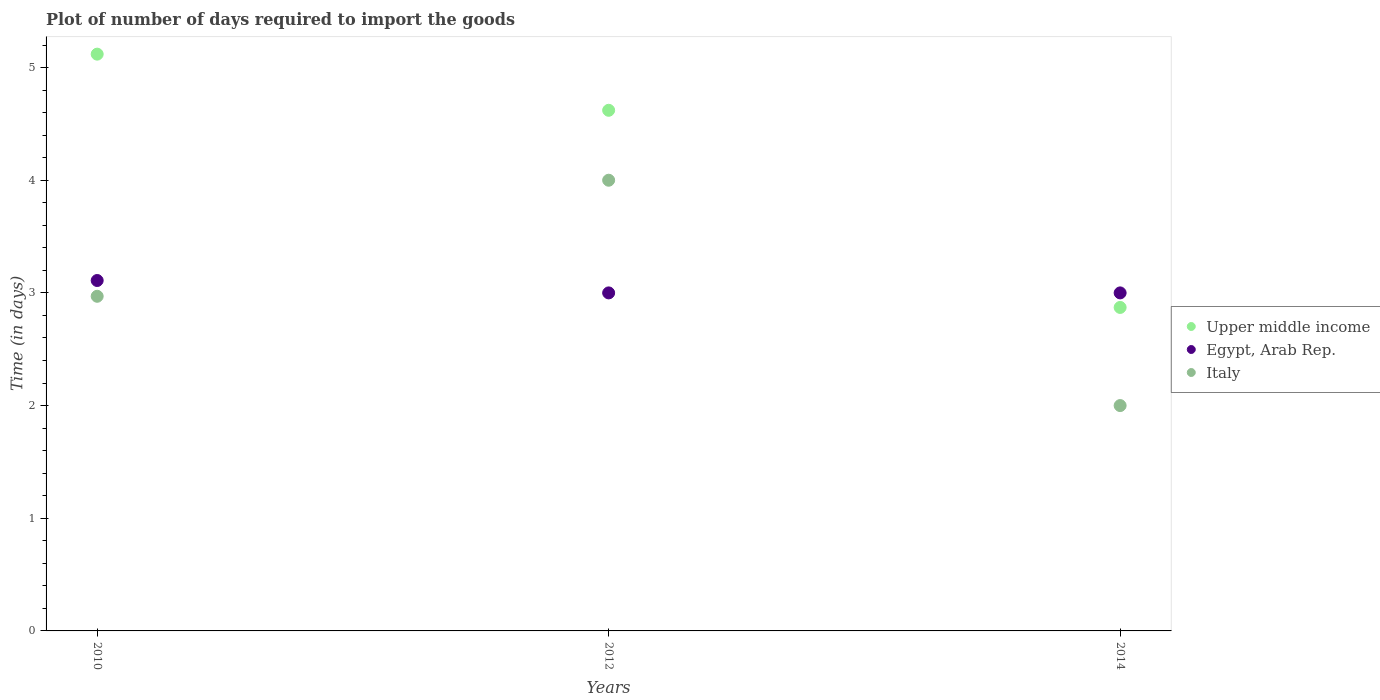How many different coloured dotlines are there?
Offer a very short reply. 3. What is the time required to import goods in Upper middle income in 2010?
Ensure brevity in your answer.  5.12. Across all years, what is the maximum time required to import goods in Egypt, Arab Rep.?
Give a very brief answer. 3.11. Across all years, what is the minimum time required to import goods in Upper middle income?
Your answer should be very brief. 2.87. In which year was the time required to import goods in Egypt, Arab Rep. maximum?
Your response must be concise. 2010. What is the total time required to import goods in Egypt, Arab Rep. in the graph?
Give a very brief answer. 9.11. What is the difference between the time required to import goods in Egypt, Arab Rep. in 2010 and that in 2012?
Keep it short and to the point. 0.11. What is the difference between the time required to import goods in Italy in 2014 and the time required to import goods in Upper middle income in 2010?
Provide a short and direct response. -3.12. What is the average time required to import goods in Italy per year?
Give a very brief answer. 2.99. What is the ratio of the time required to import goods in Upper middle income in 2010 to that in 2014?
Provide a succinct answer. 1.78. Is the difference between the time required to import goods in Italy in 2012 and 2014 greater than the difference between the time required to import goods in Egypt, Arab Rep. in 2012 and 2014?
Offer a terse response. Yes. What is the difference between the highest and the second highest time required to import goods in Italy?
Make the answer very short. 1.03. What is the difference between the highest and the lowest time required to import goods in Upper middle income?
Provide a short and direct response. 2.25. Is it the case that in every year, the sum of the time required to import goods in Italy and time required to import goods in Upper middle income  is greater than the time required to import goods in Egypt, Arab Rep.?
Your response must be concise. Yes. Is the time required to import goods in Italy strictly greater than the time required to import goods in Egypt, Arab Rep. over the years?
Offer a very short reply. No. Is the time required to import goods in Upper middle income strictly less than the time required to import goods in Egypt, Arab Rep. over the years?
Your answer should be very brief. No. How many years are there in the graph?
Make the answer very short. 3. What is the difference between two consecutive major ticks on the Y-axis?
Make the answer very short. 1. Does the graph contain any zero values?
Give a very brief answer. No. Does the graph contain grids?
Keep it short and to the point. No. How are the legend labels stacked?
Make the answer very short. Vertical. What is the title of the graph?
Make the answer very short. Plot of number of days required to import the goods. What is the label or title of the Y-axis?
Provide a short and direct response. Time (in days). What is the Time (in days) in Upper middle income in 2010?
Offer a terse response. 5.12. What is the Time (in days) of Egypt, Arab Rep. in 2010?
Your response must be concise. 3.11. What is the Time (in days) in Italy in 2010?
Offer a very short reply. 2.97. What is the Time (in days) in Upper middle income in 2012?
Keep it short and to the point. 4.62. What is the Time (in days) of Italy in 2012?
Keep it short and to the point. 4. What is the Time (in days) in Upper middle income in 2014?
Keep it short and to the point. 2.87. What is the Time (in days) of Italy in 2014?
Make the answer very short. 2. Across all years, what is the maximum Time (in days) of Upper middle income?
Provide a short and direct response. 5.12. Across all years, what is the maximum Time (in days) in Egypt, Arab Rep.?
Your answer should be compact. 3.11. Across all years, what is the minimum Time (in days) of Upper middle income?
Your answer should be very brief. 2.87. Across all years, what is the minimum Time (in days) in Egypt, Arab Rep.?
Give a very brief answer. 3. Across all years, what is the minimum Time (in days) of Italy?
Ensure brevity in your answer.  2. What is the total Time (in days) in Upper middle income in the graph?
Provide a short and direct response. 12.61. What is the total Time (in days) of Egypt, Arab Rep. in the graph?
Ensure brevity in your answer.  9.11. What is the total Time (in days) of Italy in the graph?
Make the answer very short. 8.97. What is the difference between the Time (in days) of Upper middle income in 2010 and that in 2012?
Keep it short and to the point. 0.5. What is the difference between the Time (in days) of Egypt, Arab Rep. in 2010 and that in 2012?
Provide a short and direct response. 0.11. What is the difference between the Time (in days) of Italy in 2010 and that in 2012?
Offer a very short reply. -1.03. What is the difference between the Time (in days) of Upper middle income in 2010 and that in 2014?
Offer a very short reply. 2.25. What is the difference between the Time (in days) in Egypt, Arab Rep. in 2010 and that in 2014?
Provide a succinct answer. 0.11. What is the difference between the Time (in days) in Upper middle income in 2012 and that in 2014?
Your answer should be very brief. 1.75. What is the difference between the Time (in days) in Italy in 2012 and that in 2014?
Keep it short and to the point. 2. What is the difference between the Time (in days) in Upper middle income in 2010 and the Time (in days) in Egypt, Arab Rep. in 2012?
Ensure brevity in your answer.  2.12. What is the difference between the Time (in days) in Upper middle income in 2010 and the Time (in days) in Italy in 2012?
Provide a short and direct response. 1.12. What is the difference between the Time (in days) in Egypt, Arab Rep. in 2010 and the Time (in days) in Italy in 2012?
Your answer should be compact. -0.89. What is the difference between the Time (in days) of Upper middle income in 2010 and the Time (in days) of Egypt, Arab Rep. in 2014?
Your answer should be compact. 2.12. What is the difference between the Time (in days) of Upper middle income in 2010 and the Time (in days) of Italy in 2014?
Make the answer very short. 3.12. What is the difference between the Time (in days) of Egypt, Arab Rep. in 2010 and the Time (in days) of Italy in 2014?
Make the answer very short. 1.11. What is the difference between the Time (in days) of Upper middle income in 2012 and the Time (in days) of Egypt, Arab Rep. in 2014?
Keep it short and to the point. 1.62. What is the difference between the Time (in days) in Upper middle income in 2012 and the Time (in days) in Italy in 2014?
Provide a short and direct response. 2.62. What is the average Time (in days) in Upper middle income per year?
Offer a very short reply. 4.2. What is the average Time (in days) of Egypt, Arab Rep. per year?
Give a very brief answer. 3.04. What is the average Time (in days) in Italy per year?
Give a very brief answer. 2.99. In the year 2010, what is the difference between the Time (in days) in Upper middle income and Time (in days) in Egypt, Arab Rep.?
Make the answer very short. 2.01. In the year 2010, what is the difference between the Time (in days) in Upper middle income and Time (in days) in Italy?
Your response must be concise. 2.15. In the year 2010, what is the difference between the Time (in days) in Egypt, Arab Rep. and Time (in days) in Italy?
Offer a terse response. 0.14. In the year 2012, what is the difference between the Time (in days) in Upper middle income and Time (in days) in Egypt, Arab Rep.?
Offer a very short reply. 1.62. In the year 2012, what is the difference between the Time (in days) in Upper middle income and Time (in days) in Italy?
Keep it short and to the point. 0.62. In the year 2014, what is the difference between the Time (in days) in Upper middle income and Time (in days) in Egypt, Arab Rep.?
Offer a very short reply. -0.13. In the year 2014, what is the difference between the Time (in days) in Upper middle income and Time (in days) in Italy?
Your answer should be very brief. 0.87. In the year 2014, what is the difference between the Time (in days) of Egypt, Arab Rep. and Time (in days) of Italy?
Ensure brevity in your answer.  1. What is the ratio of the Time (in days) in Upper middle income in 2010 to that in 2012?
Offer a terse response. 1.11. What is the ratio of the Time (in days) of Egypt, Arab Rep. in 2010 to that in 2012?
Provide a succinct answer. 1.04. What is the ratio of the Time (in days) in Italy in 2010 to that in 2012?
Offer a terse response. 0.74. What is the ratio of the Time (in days) of Upper middle income in 2010 to that in 2014?
Provide a short and direct response. 1.78. What is the ratio of the Time (in days) in Egypt, Arab Rep. in 2010 to that in 2014?
Your answer should be compact. 1.04. What is the ratio of the Time (in days) in Italy in 2010 to that in 2014?
Your answer should be compact. 1.49. What is the ratio of the Time (in days) in Upper middle income in 2012 to that in 2014?
Your answer should be very brief. 1.61. What is the ratio of the Time (in days) in Italy in 2012 to that in 2014?
Provide a short and direct response. 2. What is the difference between the highest and the second highest Time (in days) of Upper middle income?
Your answer should be compact. 0.5. What is the difference between the highest and the second highest Time (in days) of Egypt, Arab Rep.?
Provide a succinct answer. 0.11. What is the difference between the highest and the lowest Time (in days) in Upper middle income?
Make the answer very short. 2.25. What is the difference between the highest and the lowest Time (in days) in Egypt, Arab Rep.?
Your response must be concise. 0.11. 